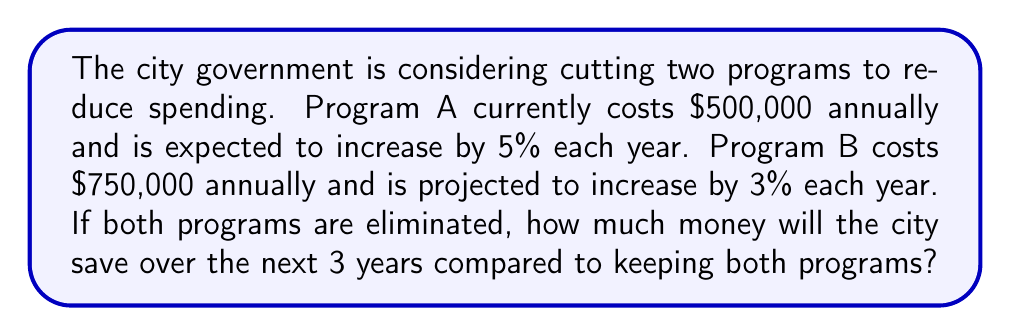Give your solution to this math problem. Let's approach this step-by-step:

1) First, let's calculate the cost of Program A for each year:
   Year 1: $500,000
   Year 2: $500,000 * 1.05 = $525,000
   Year 3: $525,000 * 1.05 = $551,250

2) Now, let's calculate the cost of Program B for each year:
   Year 1: $750,000
   Year 2: $750,000 * 1.03 = $772,500
   Year 3: $772,500 * 1.03 = $795,675

3) Let's sum up the costs for both programs over 3 years:
   Program A: $500,000 + $525,000 + $551,250 = $1,576,250
   Program B: $750,000 + $772,500 + $795,675 = $2,318,175

4) The total cost of both programs over 3 years is:
   $1,576,250 + $2,318,175 = $3,894,425

5) If both programs are eliminated, this is the amount the city will save over 3 years.

We can express this mathematically as:

$$S = \sum_{i=0}^{2} (A * 1.05^i + B * 1.03^i)$$

Where $S$ is the total savings, $A$ is the initial cost of Program A, and $B$ is the initial cost of Program B.
Answer: $3,894,425 